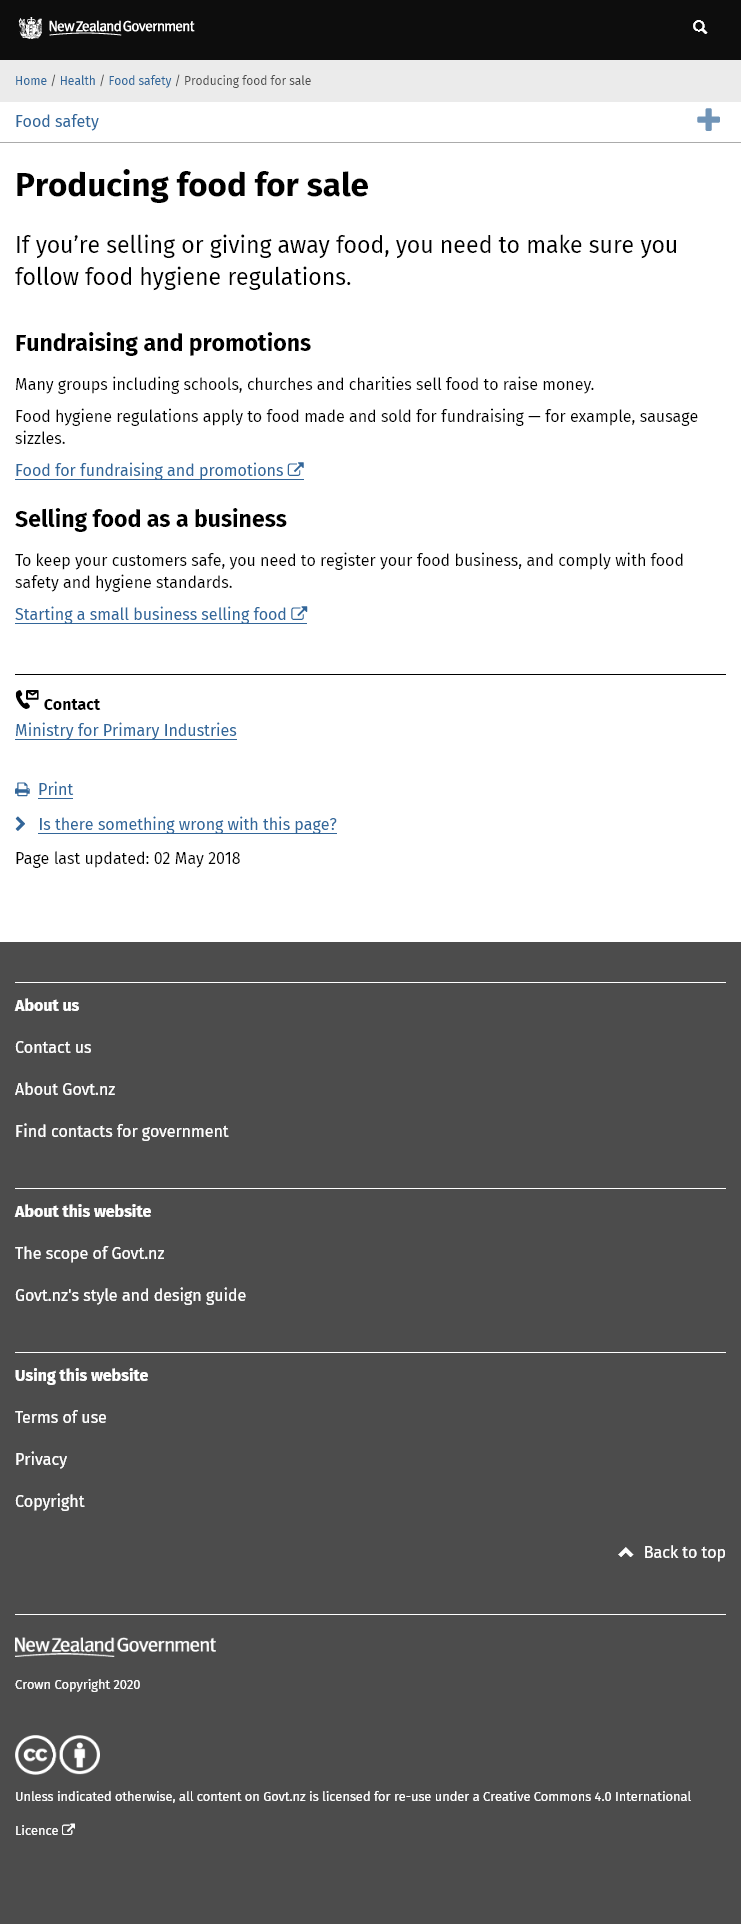Specify some key components in this picture. Sausage sizzles are a popular example of food made and sold for fundraising purposes. Many groups, such as schools, churches, and charities, sell food to raise money. To ensure the safety of customers when selling food as a business, it is necessary to register the business and comply with food safety and hygiene standards. 